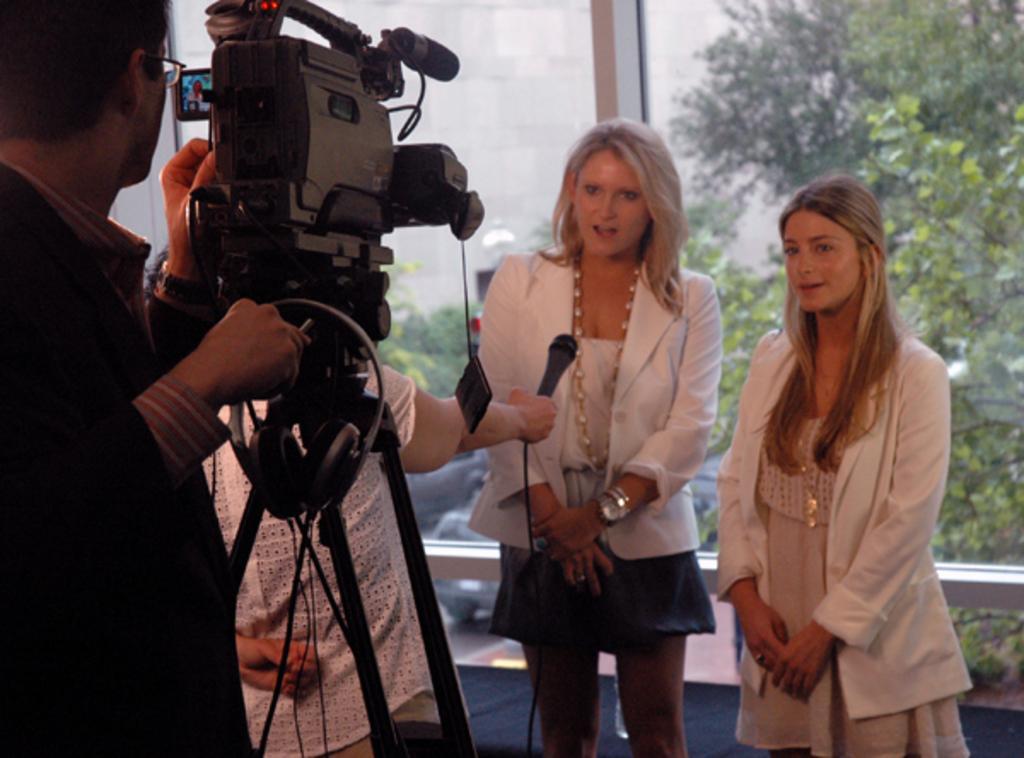Can you describe this image briefly? On the right side a beautiful woman is standing and speaking. She wore white color coat, beside her there is another woman. On the left side a man is operating the camera, behind them it's a glass wall. 